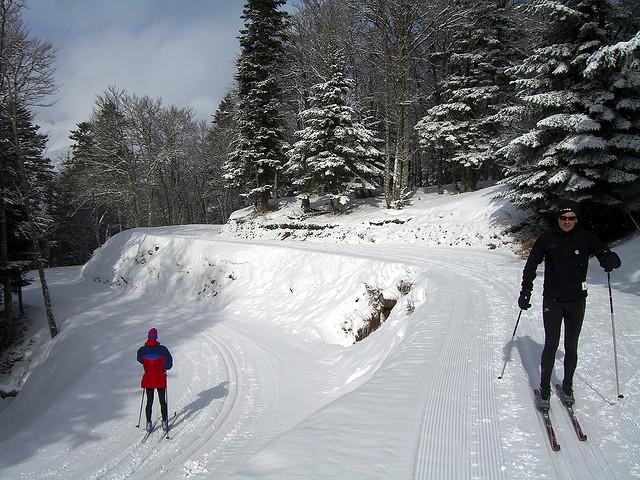Are both skiers on the same track?
Short answer required. No. What color is the skier on the left's jacket?
Give a very brief answer. Red and blue. Are these two cross country skiers moving in the same direction?
Write a very short answer. No. 